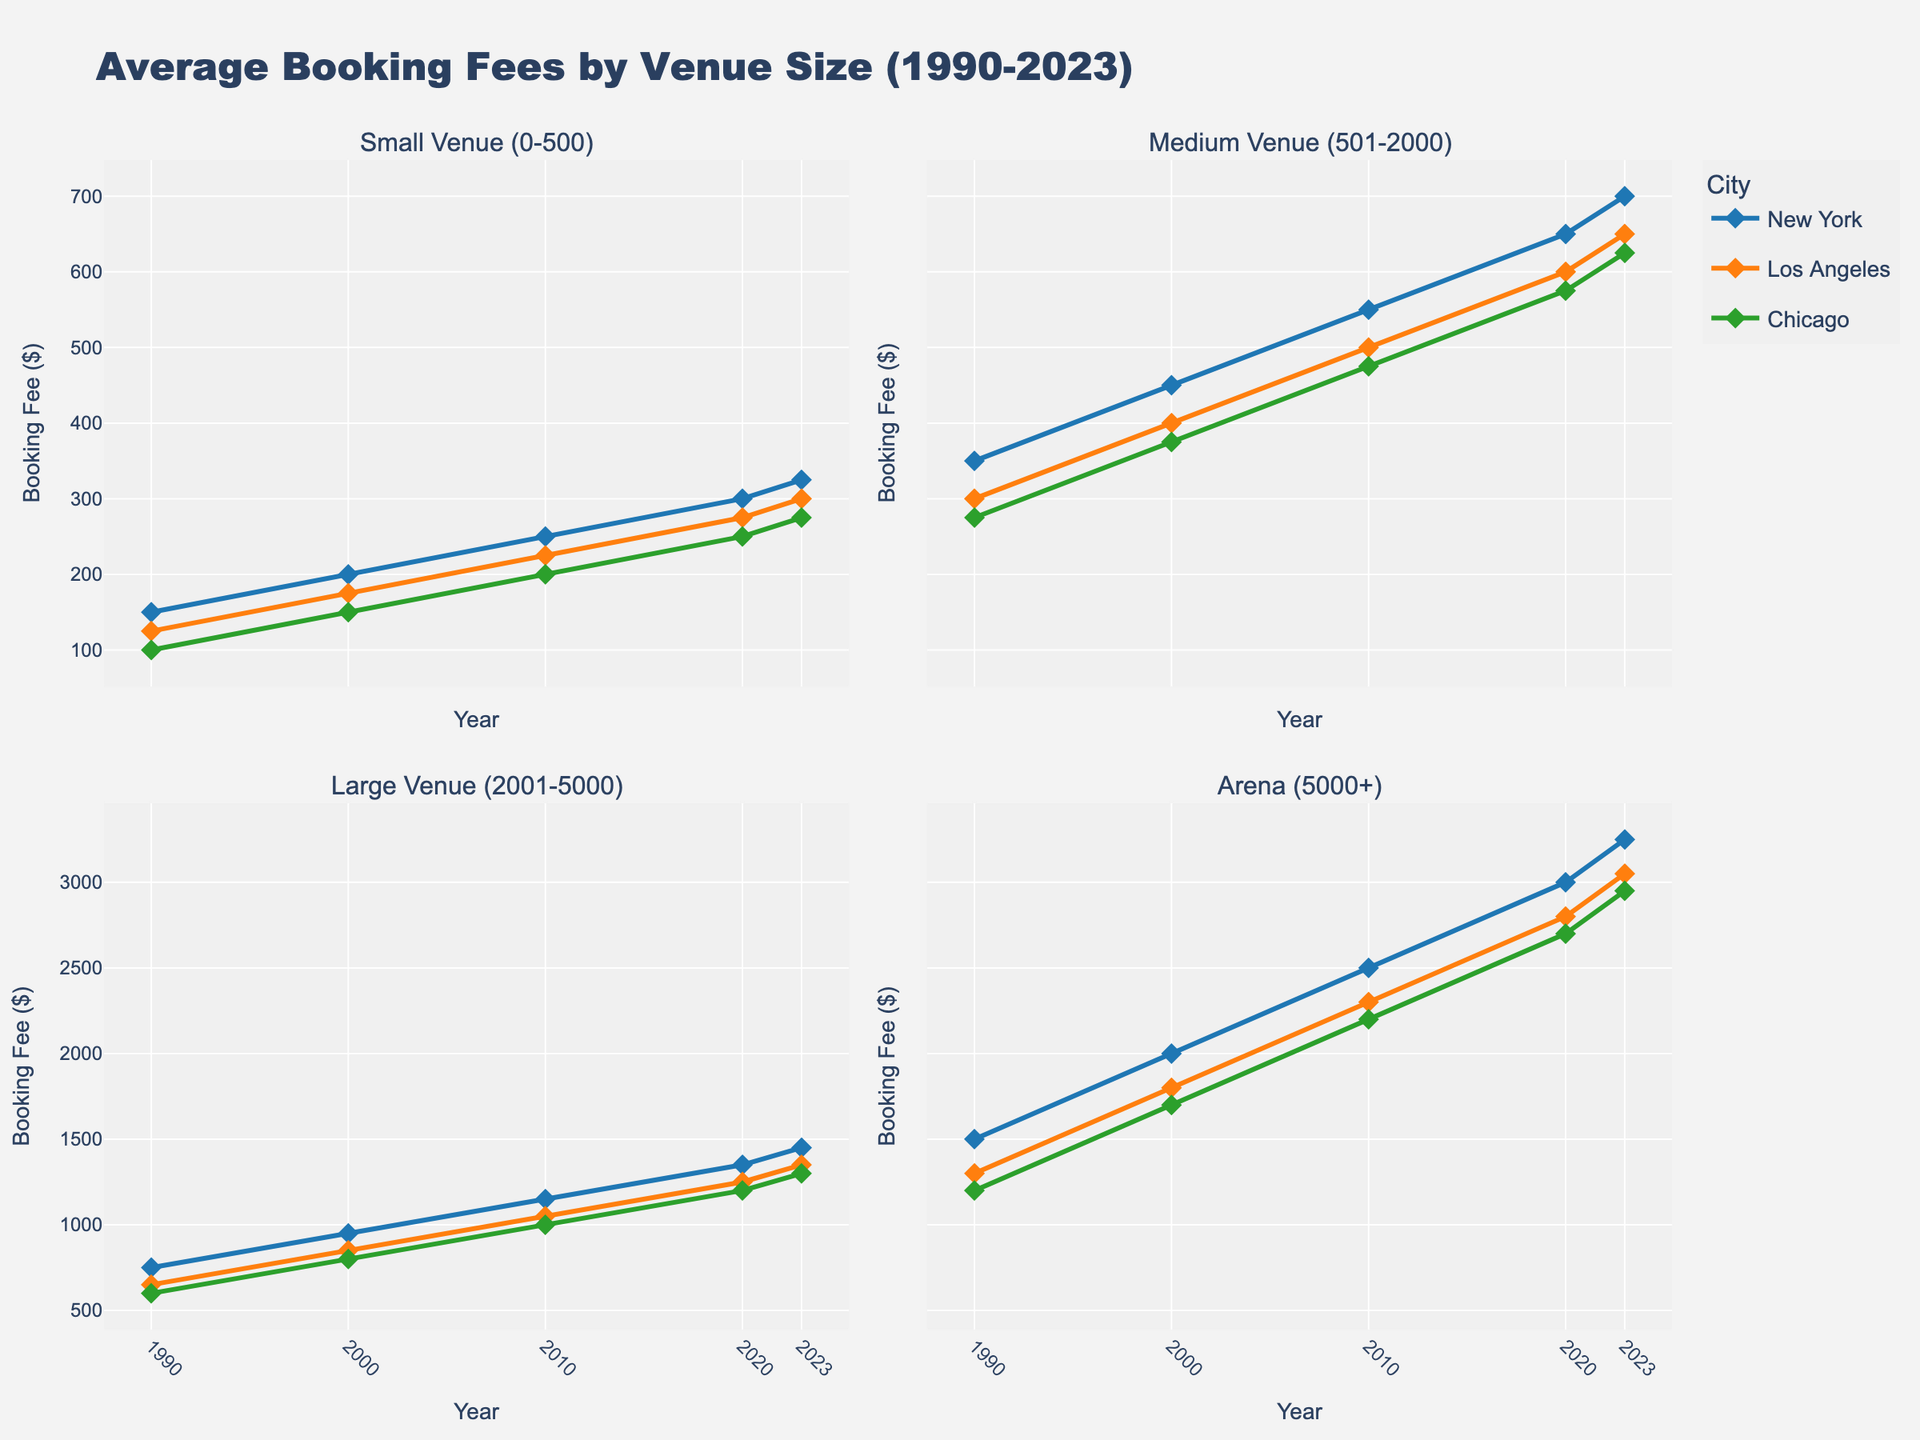what is the title of the figure? The title of the figure is displayed at the top and provides a summary of the data being visualized. Referring to the figure, the title reads "Average Booking Fees by Venue Size (1990-2023)"
Answer: Average Booking Fees by Venue Size (1990-2023) How does the booking fee for New York arenas change from 1990 to 2023? By examining the line representing New York under Arena (5000+) in the subplots, we see the booking fee increments from 1500 in 1990 to 3250 in 2023. There is a clear upward trend
Answer: Increases from 1500 to 3250 Which city had the highest booking fee for small venues in 2023 and what was it? Review the subplots titled Small Venue (0-500). In 2023, New York has the highest booking fee among the cities, reaching 325
Answer: New York with 325 What is the difference in booking fees for medium venues between Los Angeles and Chicago in 2010? Look at the Medium Venue (501-2000) subplot. In 2010, Los Angeles's booking fee stands at 500, while Chicago's stands at 475. The difference is 500 - 475 = 25
Answer: 25 Between 2000 and 2020, which city saw the greatest increase in booking fees for large venues (2001-5000)? In Large Venue (2001-5000) subplot, for New York, fees increased from 950 (2000) to 1350 (2020); for Los Angeles, 850 to 1250; for Chicago, 800 to 1200. The biggest increase is by New York: 1350 - 950 = 400
Answer: New York What trend can be observed in the booking fees for arenas across all cities from 1990 to 2023? By analyzing the Arena (5000+) subplot, an upward trend in booking fees is evident for all three cities from 1990 to 2023
Answer: Upward trend In 2000, which city had the lowest booking fee for small venues, and what was its fee? In the Small Venue (0-500) subplot, Chicago's booking fee in 2000 is the lowest at 150, compared to New York and Los Angeles
Answer: Chicago with 150 What are the booking fees for medium venues for all cities in 2023? Refer to the Medium Venue (501-2000) subplot; in 2023, New York is 700, Los Angeles is 650, and Chicago is 625
Answer: New York 700, Los Angeles 650, Chicago 625 Which venue size saw the least variation in booking fees across the three cities in 1990? In 1990, compare the variations across the subplots: Small Venue (0-500), Medium Venue (501-2000), Large Venue (2001-5000), Arena (5000+). The Small Venue (0-500) subplot shows the least variation among New York (150), Los Angeles (125), and Chicago (100), having a range of 50
Answer: Small Venue (0-500) How do the booking fees trend for large venues in Chicago from 1990 to 2023? The Large Venue (2001-5000) subplot shows that Chicago's booking fees increase from 600 (1990), 800 (2000), 1000 (2010), 1200 (2020) to 1300 (2023), showing a consistent upward trend
Answer: Consistently upward 